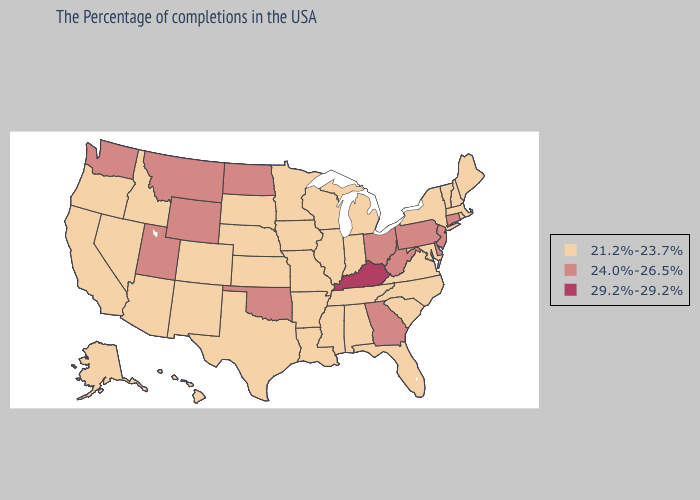Does the map have missing data?
Answer briefly. No. Does New Hampshire have the lowest value in the USA?
Write a very short answer. Yes. Does Ohio have the lowest value in the USA?
Short answer required. No. Does the first symbol in the legend represent the smallest category?
Quick response, please. Yes. What is the value of Florida?
Be succinct. 21.2%-23.7%. What is the lowest value in states that border New Jersey?
Quick response, please. 21.2%-23.7%. Does Kansas have the lowest value in the MidWest?
Keep it brief. Yes. Does New Jersey have the lowest value in the Northeast?
Answer briefly. No. Does Hawaii have the lowest value in the USA?
Write a very short answer. Yes. Does Nevada have a lower value than Rhode Island?
Short answer required. No. Which states have the lowest value in the USA?
Keep it brief. Maine, Massachusetts, Rhode Island, New Hampshire, Vermont, New York, Maryland, Virginia, North Carolina, South Carolina, Florida, Michigan, Indiana, Alabama, Tennessee, Wisconsin, Illinois, Mississippi, Louisiana, Missouri, Arkansas, Minnesota, Iowa, Kansas, Nebraska, Texas, South Dakota, Colorado, New Mexico, Arizona, Idaho, Nevada, California, Oregon, Alaska, Hawaii. What is the value of North Carolina?
Write a very short answer. 21.2%-23.7%. Name the states that have a value in the range 24.0%-26.5%?
Be succinct. Connecticut, New Jersey, Delaware, Pennsylvania, West Virginia, Ohio, Georgia, Oklahoma, North Dakota, Wyoming, Utah, Montana, Washington. Does West Virginia have a higher value than Nebraska?
Give a very brief answer. Yes. What is the lowest value in the MidWest?
Be succinct. 21.2%-23.7%. 